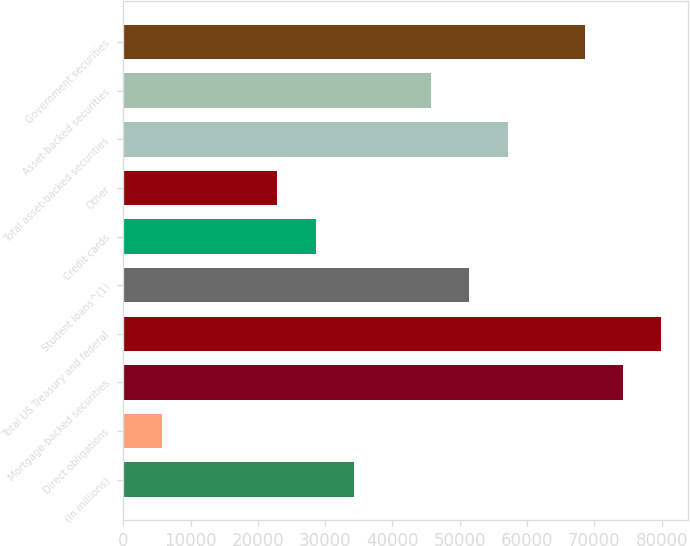<chart> <loc_0><loc_0><loc_500><loc_500><bar_chart><fcel>(In millions)<fcel>Direct obligations<fcel>Mortgage-backed securities<fcel>Total US Treasury and federal<fcel>Student loans^(1)<fcel>Credit cards<fcel>Other<fcel>Total asset-backed securities<fcel>Asset-backed securities<fcel>Government securities<nl><fcel>34291<fcel>5753.5<fcel>74243.5<fcel>79951<fcel>51413.5<fcel>28583.5<fcel>22876<fcel>57121<fcel>45706<fcel>68536<nl></chart> 